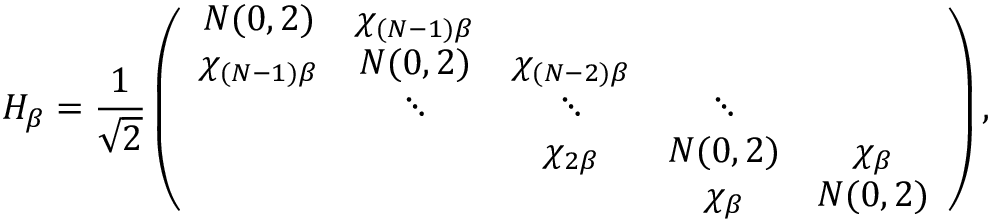<formula> <loc_0><loc_0><loc_500><loc_500>H _ { \beta } = \frac { 1 } { \sqrt { 2 } } \left ( \begin{array} { c c c c c } { N ( 0 , 2 ) } & { \chi _ { ( N - 1 ) \beta } } & & & \\ { \chi _ { ( N - 1 ) \beta } } & { N ( 0 , 2 ) } & { \chi _ { ( N - 2 ) \beta } } & & \\ & { \ddots } & { \ddots } & { \ddots } & \\ & & { \chi _ { 2 \beta } } & { N ( 0 , 2 ) } & { \chi _ { \beta } } \\ & & & { \chi _ { \beta } } & { N ( 0 , 2 ) } \end{array} \right ) ,</formula> 